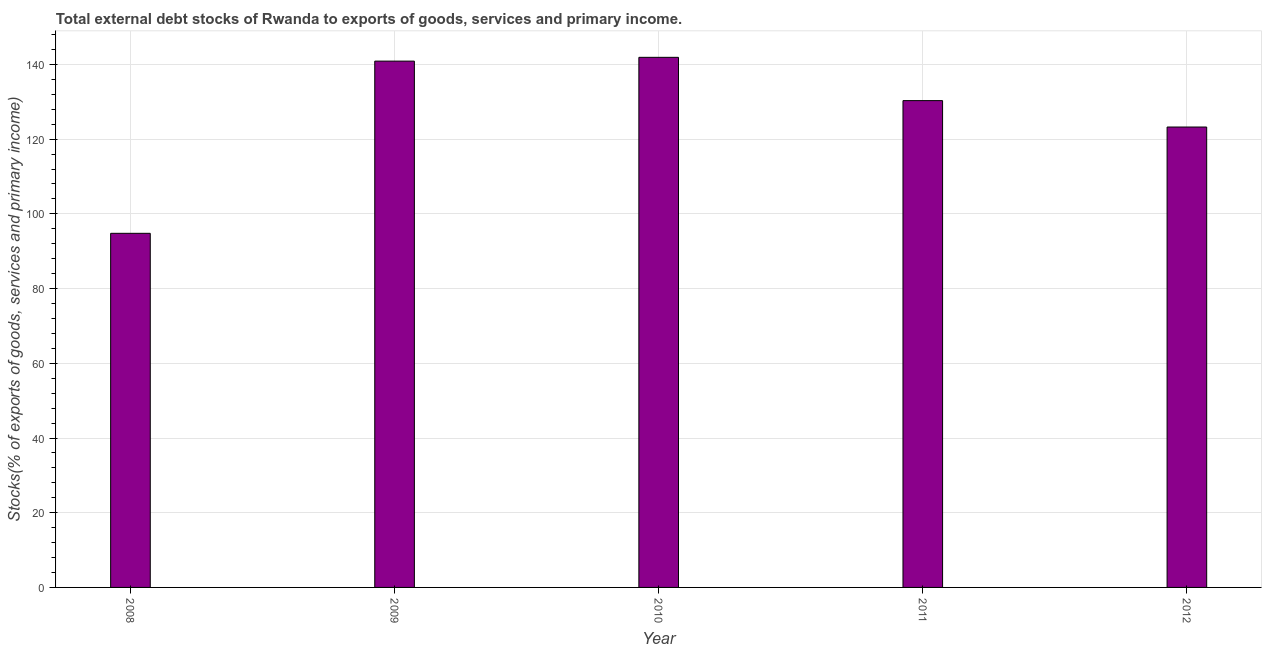Does the graph contain any zero values?
Give a very brief answer. No. What is the title of the graph?
Offer a very short reply. Total external debt stocks of Rwanda to exports of goods, services and primary income. What is the label or title of the Y-axis?
Provide a succinct answer. Stocks(% of exports of goods, services and primary income). What is the external debt stocks in 2012?
Provide a succinct answer. 123.25. Across all years, what is the maximum external debt stocks?
Offer a terse response. 141.9. Across all years, what is the minimum external debt stocks?
Provide a succinct answer. 94.79. In which year was the external debt stocks minimum?
Offer a very short reply. 2008. What is the sum of the external debt stocks?
Your answer should be compact. 631.15. What is the difference between the external debt stocks in 2008 and 2011?
Your answer should be very brief. -35.52. What is the average external debt stocks per year?
Your answer should be compact. 126.23. What is the median external debt stocks?
Offer a terse response. 130.32. Do a majority of the years between 2008 and 2009 (inclusive) have external debt stocks greater than 88 %?
Provide a succinct answer. Yes. What is the ratio of the external debt stocks in 2010 to that in 2012?
Give a very brief answer. 1.15. Is the external debt stocks in 2010 less than that in 2012?
Keep it short and to the point. No. Is the difference between the external debt stocks in 2011 and 2012 greater than the difference between any two years?
Your response must be concise. No. Is the sum of the external debt stocks in 2008 and 2011 greater than the maximum external debt stocks across all years?
Provide a short and direct response. Yes. What is the difference between the highest and the lowest external debt stocks?
Provide a short and direct response. 47.11. In how many years, is the external debt stocks greater than the average external debt stocks taken over all years?
Offer a terse response. 3. How many bars are there?
Keep it short and to the point. 5. What is the difference between two consecutive major ticks on the Y-axis?
Keep it short and to the point. 20. Are the values on the major ticks of Y-axis written in scientific E-notation?
Ensure brevity in your answer.  No. What is the Stocks(% of exports of goods, services and primary income) in 2008?
Ensure brevity in your answer.  94.79. What is the Stocks(% of exports of goods, services and primary income) in 2009?
Offer a very short reply. 140.89. What is the Stocks(% of exports of goods, services and primary income) of 2010?
Your answer should be compact. 141.9. What is the Stocks(% of exports of goods, services and primary income) of 2011?
Give a very brief answer. 130.32. What is the Stocks(% of exports of goods, services and primary income) in 2012?
Your response must be concise. 123.25. What is the difference between the Stocks(% of exports of goods, services and primary income) in 2008 and 2009?
Your response must be concise. -46.1. What is the difference between the Stocks(% of exports of goods, services and primary income) in 2008 and 2010?
Give a very brief answer. -47.11. What is the difference between the Stocks(% of exports of goods, services and primary income) in 2008 and 2011?
Your answer should be compact. -35.52. What is the difference between the Stocks(% of exports of goods, services and primary income) in 2008 and 2012?
Offer a terse response. -28.46. What is the difference between the Stocks(% of exports of goods, services and primary income) in 2009 and 2010?
Give a very brief answer. -1.01. What is the difference between the Stocks(% of exports of goods, services and primary income) in 2009 and 2011?
Provide a short and direct response. 10.58. What is the difference between the Stocks(% of exports of goods, services and primary income) in 2009 and 2012?
Your answer should be compact. 17.64. What is the difference between the Stocks(% of exports of goods, services and primary income) in 2010 and 2011?
Make the answer very short. 11.59. What is the difference between the Stocks(% of exports of goods, services and primary income) in 2010 and 2012?
Offer a terse response. 18.66. What is the difference between the Stocks(% of exports of goods, services and primary income) in 2011 and 2012?
Your response must be concise. 7.07. What is the ratio of the Stocks(% of exports of goods, services and primary income) in 2008 to that in 2009?
Provide a short and direct response. 0.67. What is the ratio of the Stocks(% of exports of goods, services and primary income) in 2008 to that in 2010?
Give a very brief answer. 0.67. What is the ratio of the Stocks(% of exports of goods, services and primary income) in 2008 to that in 2011?
Make the answer very short. 0.73. What is the ratio of the Stocks(% of exports of goods, services and primary income) in 2008 to that in 2012?
Keep it short and to the point. 0.77. What is the ratio of the Stocks(% of exports of goods, services and primary income) in 2009 to that in 2011?
Offer a very short reply. 1.08. What is the ratio of the Stocks(% of exports of goods, services and primary income) in 2009 to that in 2012?
Your response must be concise. 1.14. What is the ratio of the Stocks(% of exports of goods, services and primary income) in 2010 to that in 2011?
Give a very brief answer. 1.09. What is the ratio of the Stocks(% of exports of goods, services and primary income) in 2010 to that in 2012?
Give a very brief answer. 1.15. What is the ratio of the Stocks(% of exports of goods, services and primary income) in 2011 to that in 2012?
Offer a very short reply. 1.06. 